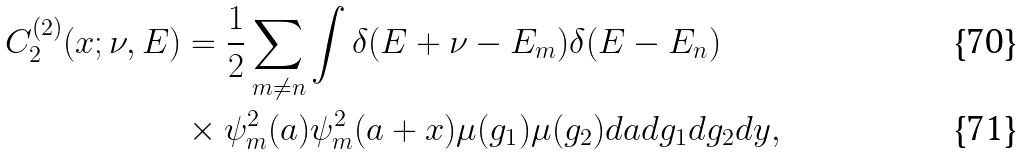<formula> <loc_0><loc_0><loc_500><loc_500>C _ { 2 } ^ { ( 2 ) } ( x ; \nu , E ) & = \frac { 1 } { 2 } \sum _ { m \neq n } \int \delta ( E + \nu - E _ { m } ) \delta ( E - E _ { n } ) \\ & \times \psi _ { m } ^ { 2 } ( a ) \psi _ { m } ^ { 2 } ( a + x ) \mu ( g _ { 1 } ) \mu ( g _ { 2 } ) d a d g _ { 1 } d g _ { 2 } d y ,</formula> 